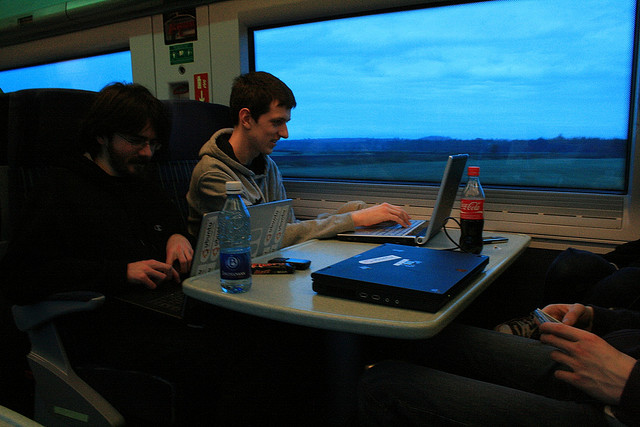Please transcribe the text information in this image. Cola 